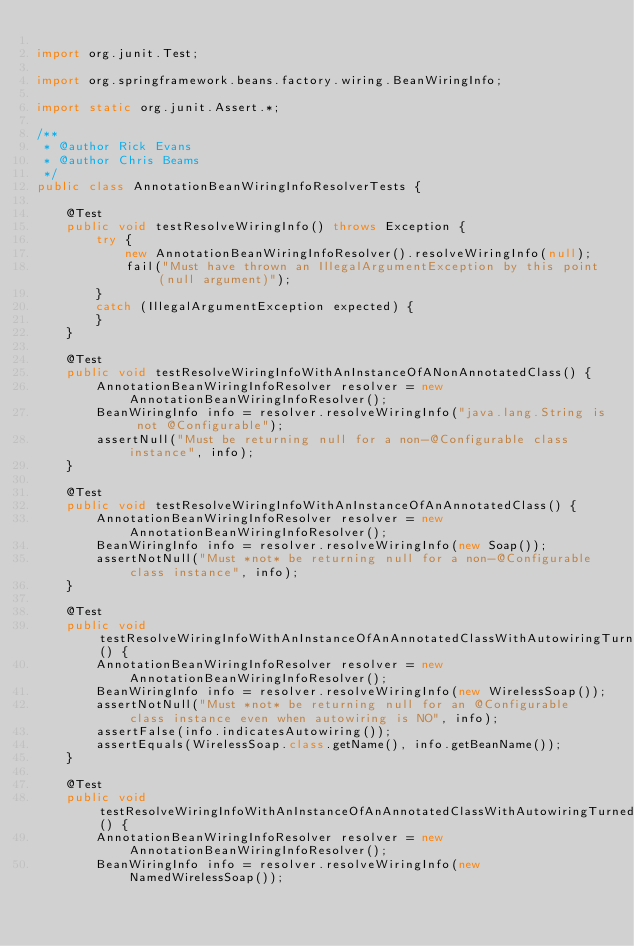Convert code to text. <code><loc_0><loc_0><loc_500><loc_500><_Java_>
import org.junit.Test;

import org.springframework.beans.factory.wiring.BeanWiringInfo;

import static org.junit.Assert.*;

/**
 * @author Rick Evans
 * @author Chris Beams
 */
public class AnnotationBeanWiringInfoResolverTests {

	@Test
	public void testResolveWiringInfo() throws Exception {
		try {
			new AnnotationBeanWiringInfoResolver().resolveWiringInfo(null);
			fail("Must have thrown an IllegalArgumentException by this point (null argument)");
		}
		catch (IllegalArgumentException expected) {
		}
	}

	@Test
	public void testResolveWiringInfoWithAnInstanceOfANonAnnotatedClass() {
		AnnotationBeanWiringInfoResolver resolver = new AnnotationBeanWiringInfoResolver();
		BeanWiringInfo info = resolver.resolveWiringInfo("java.lang.String is not @Configurable");
		assertNull("Must be returning null for a non-@Configurable class instance", info);
	}

	@Test
	public void testResolveWiringInfoWithAnInstanceOfAnAnnotatedClass() {
		AnnotationBeanWiringInfoResolver resolver = new AnnotationBeanWiringInfoResolver();
		BeanWiringInfo info = resolver.resolveWiringInfo(new Soap());
		assertNotNull("Must *not* be returning null for a non-@Configurable class instance", info);
	}

	@Test
	public void testResolveWiringInfoWithAnInstanceOfAnAnnotatedClassWithAutowiringTurnedOffExplicitly() {
		AnnotationBeanWiringInfoResolver resolver = new AnnotationBeanWiringInfoResolver();
		BeanWiringInfo info = resolver.resolveWiringInfo(new WirelessSoap());
		assertNotNull("Must *not* be returning null for an @Configurable class instance even when autowiring is NO", info);
		assertFalse(info.indicatesAutowiring());
		assertEquals(WirelessSoap.class.getName(), info.getBeanName());
	}

	@Test
	public void testResolveWiringInfoWithAnInstanceOfAnAnnotatedClassWithAutowiringTurnedOffExplicitlyAndCustomBeanName() {
		AnnotationBeanWiringInfoResolver resolver = new AnnotationBeanWiringInfoResolver();
		BeanWiringInfo info = resolver.resolveWiringInfo(new NamedWirelessSoap());</code> 